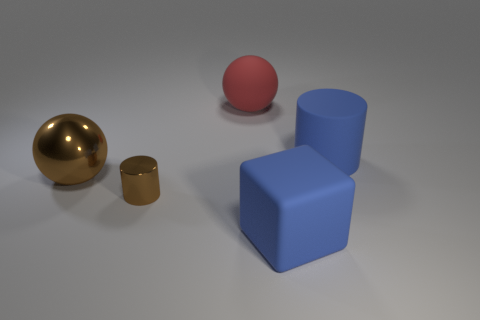Add 2 brown cylinders. How many objects exist? 7 Subtract all blocks. How many objects are left? 4 Add 5 big gray cylinders. How many big gray cylinders exist? 5 Subtract 0 purple balls. How many objects are left? 5 Subtract all yellow cylinders. Subtract all cyan spheres. How many cylinders are left? 2 Subtract all tiny red metal spheres. Subtract all blue rubber cylinders. How many objects are left? 4 Add 5 red matte balls. How many red matte balls are left? 6 